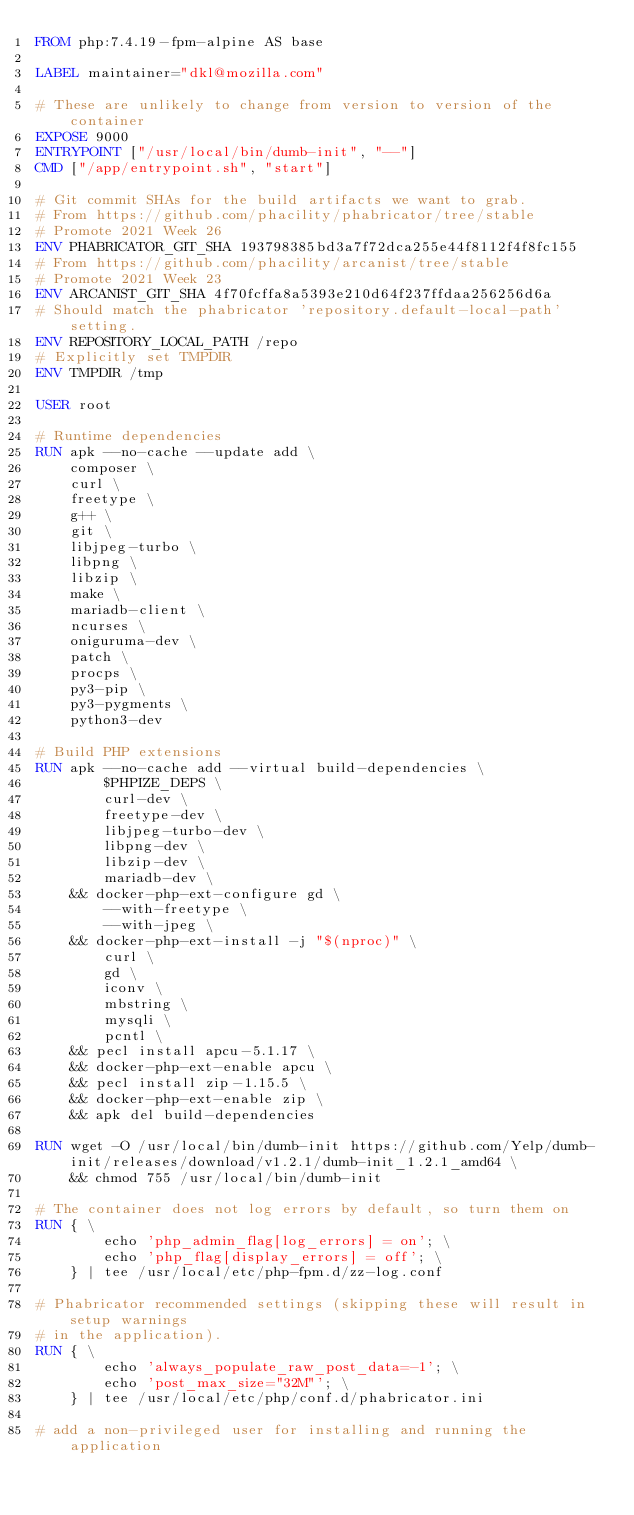<code> <loc_0><loc_0><loc_500><loc_500><_Dockerfile_>FROM php:7.4.19-fpm-alpine AS base

LABEL maintainer="dkl@mozilla.com"

# These are unlikely to change from version to version of the container
EXPOSE 9000
ENTRYPOINT ["/usr/local/bin/dumb-init", "--"]
CMD ["/app/entrypoint.sh", "start"]

# Git commit SHAs for the build artifacts we want to grab.
# From https://github.com/phacility/phabricator/tree/stable
# Promote 2021 Week 26
ENV PHABRICATOR_GIT_SHA 193798385bd3a7f72dca255e44f8112f4f8fc155
# From https://github.com/phacility/arcanist/tree/stable
# Promote 2021 Week 23
ENV ARCANIST_GIT_SHA 4f70fcffa8a5393e210d64f237ffdaa256256d6a
# Should match the phabricator 'repository.default-local-path' setting.
ENV REPOSITORY_LOCAL_PATH /repo
# Explicitly set TMPDIR
ENV TMPDIR /tmp

USER root

# Runtime dependencies
RUN apk --no-cache --update add \
    composer \
    curl \
    freetype \
    g++ \
    git \
    libjpeg-turbo \
    libpng \
    libzip \
    make \
    mariadb-client \
    ncurses \
    oniguruma-dev \
    patch \
    procps \
    py3-pip \
    py3-pygments \
    python3-dev

# Build PHP extensions
RUN apk --no-cache add --virtual build-dependencies \
        $PHPIZE_DEPS \
        curl-dev \
        freetype-dev \
        libjpeg-turbo-dev \
        libpng-dev \
        libzip-dev \
        mariadb-dev \
    && docker-php-ext-configure gd \
        --with-freetype \
        --with-jpeg \
    && docker-php-ext-install -j "$(nproc)" \
        curl \
        gd \
        iconv \
        mbstring \
        mysqli \
        pcntl \
    && pecl install apcu-5.1.17 \
    && docker-php-ext-enable apcu \
    && pecl install zip-1.15.5 \
    && docker-php-ext-enable zip \
    && apk del build-dependencies

RUN wget -O /usr/local/bin/dumb-init https://github.com/Yelp/dumb-init/releases/download/v1.2.1/dumb-init_1.2.1_amd64 \
    && chmod 755 /usr/local/bin/dumb-init

# The container does not log errors by default, so turn them on
RUN { \
        echo 'php_admin_flag[log_errors] = on'; \
        echo 'php_flag[display_errors] = off'; \
    } | tee /usr/local/etc/php-fpm.d/zz-log.conf

# Phabricator recommended settings (skipping these will result in setup warnings
# in the application).
RUN { \
        echo 'always_populate_raw_post_data=-1'; \
        echo 'post_max_size="32M"'; \
    } | tee /usr/local/etc/php/conf.d/phabricator.ini

# add a non-privileged user for installing and running the application</code> 